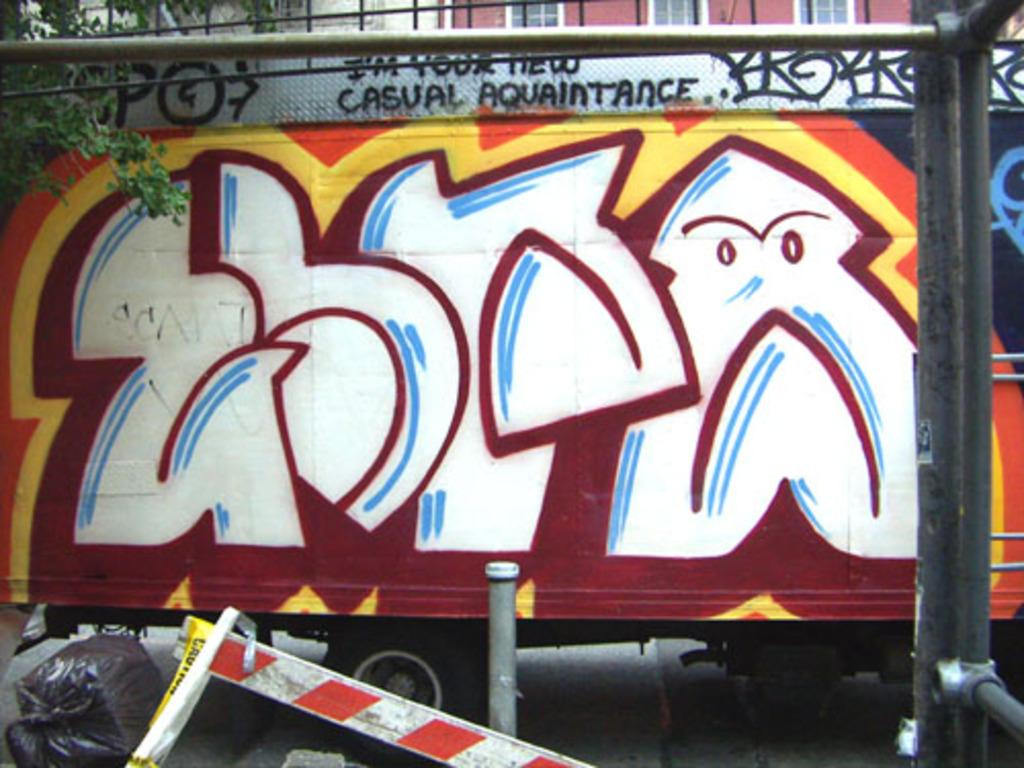What is depicted on the vehicle in the image? There is a painting on a vehicle in the image. What type of vegetation is on the left side of the image? There is a tree on the left side of the image. What structure can be seen at the top of the image? There appears to be a building at the top of the image. What type of cabbage is growing on the vehicle in the image? There is no cabbage present in the image; the main subject is a painting on a vehicle. What reaction can be seen from the tree in the image? There is no reaction from the tree in the image, as trees do not have the ability to express emotions or reactions. 